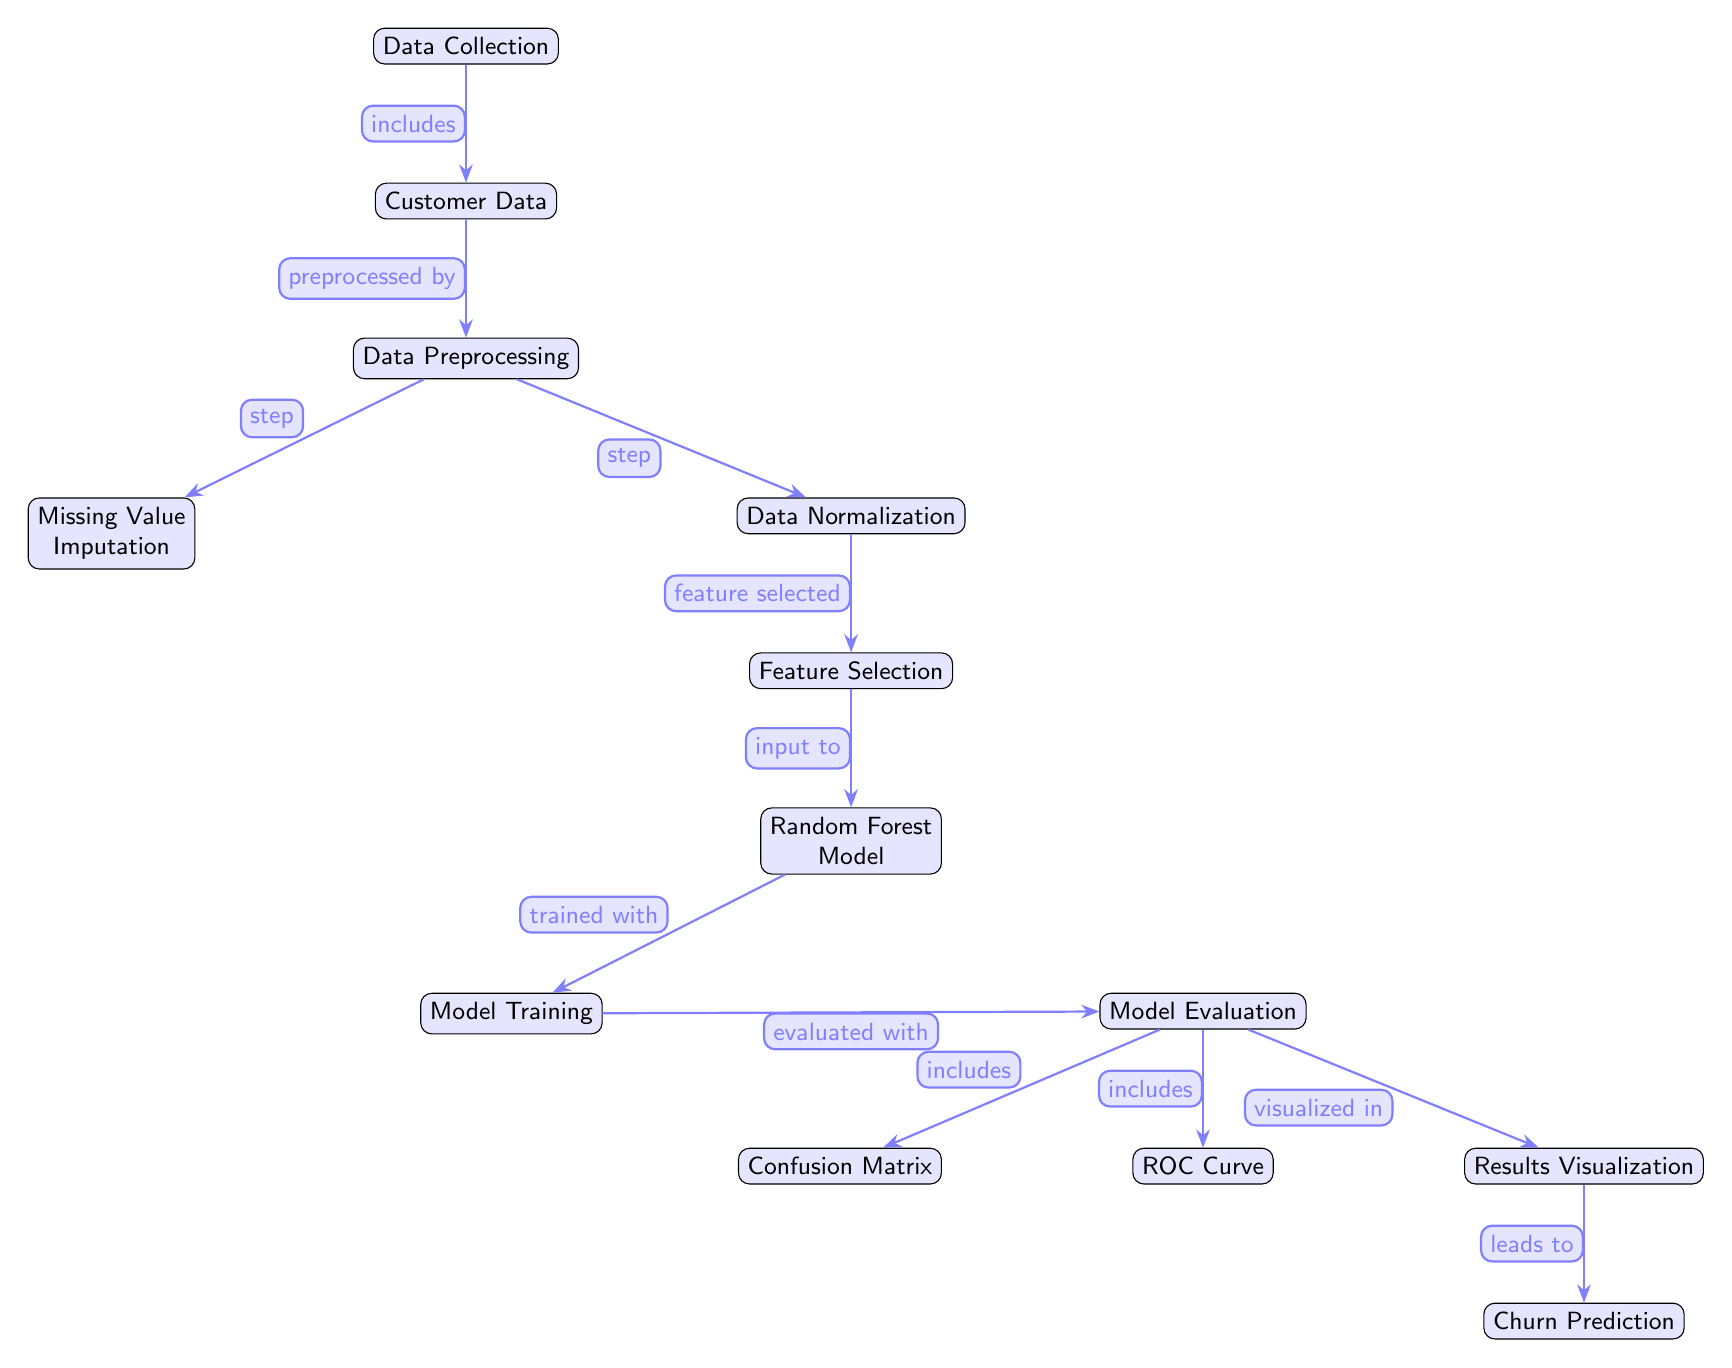What is the first step in the diagram? The first step in the diagram is represented by the topmost node labeled "Data Collection". This node initiates the flow of the process to predict customer churn.
Answer: Data Collection How many nodes are present in the diagram? By counting each distinct labeled node in the diagram, we find there are a total of 13 nodes. This reflects the various stages of predicting customer churn.
Answer: 13 What does Data Preprocessing include? Data Preprocessing includes two specific steps represented by nodes: "Missing Value Imputation" and "Data Normalization". These are essential steps to prepare the data for feature selection.
Answer: Missing Value Imputation, Data Normalization What type of model is used for prediction in the diagram? The model used for prediction is specified in the node labeled "Random Forest Model". This indicates that the random forest technique is employed for the churn prediction task.
Answer: Random Forest Model Which node leads to Churn Prediction? The node that directly connects and leads to the final result of "Churn Prediction" is "Results Visualization". This shows that the output of the visualization step presents the churn predictions.
Answer: Results Visualization What is evaluated with the model according to the diagram? The model is evaluated with a few metrics represented by nodes connected to "Model Evaluation". These include "Confusion Matrix" and "ROC Curve". Both provide insights into the model's performance.
Answer: Confusion Matrix, ROC Curve Which two processes come before Feature Selection? Before "Feature Selection", the processes that occur are "Data Normalization" and "Missing Value Imputation", as indicated by the positioning of these nodes in relation to Feature Selection.
Answer: Data Normalization, Missing Value Imputation What does the arrow labeled "trained with" connect to? The arrow labeled "trained with" connects to the node representing "Model Training", indicating that this is the stage where the random forest model is actually trained with the preprocessed and selected features.
Answer: Model Training How is the model's performance visualized? The performance of the model is visualized in the node labeled "Results Visualization", which is key for interpreting the outcomes of the model evaluation steps.
Answer: Results Visualization 